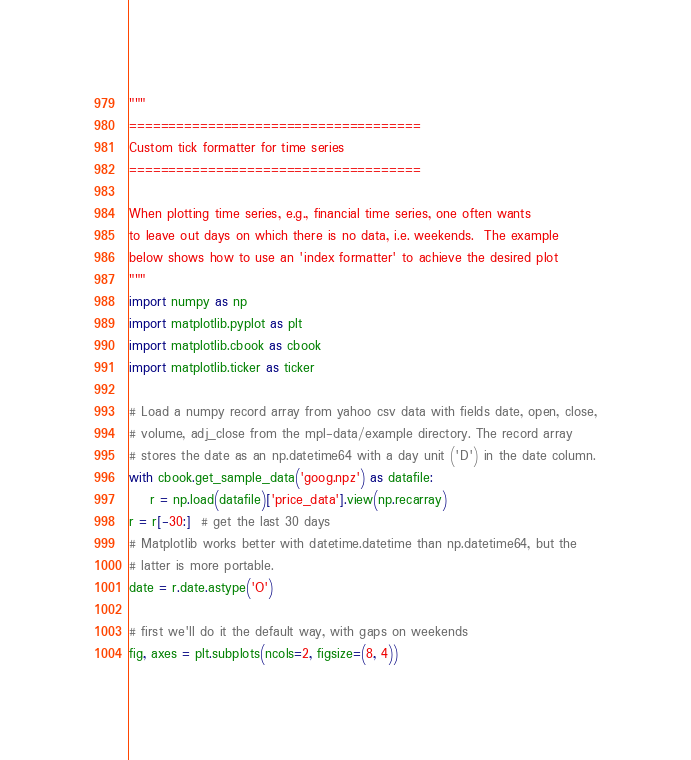<code> <loc_0><loc_0><loc_500><loc_500><_Python_>"""
=====================================
Custom tick formatter for time series
=====================================

When plotting time series, e.g., financial time series, one often wants
to leave out days on which there is no data, i.e. weekends.  The example
below shows how to use an 'index formatter' to achieve the desired plot
"""
import numpy as np
import matplotlib.pyplot as plt
import matplotlib.cbook as cbook
import matplotlib.ticker as ticker

# Load a numpy record array from yahoo csv data with fields date, open, close,
# volume, adj_close from the mpl-data/example directory. The record array
# stores the date as an np.datetime64 with a day unit ('D') in the date column.
with cbook.get_sample_data('goog.npz') as datafile:
    r = np.load(datafile)['price_data'].view(np.recarray)
r = r[-30:]  # get the last 30 days
# Matplotlib works better with datetime.datetime than np.datetime64, but the
# latter is more portable.
date = r.date.astype('O')

# first we'll do it the default way, with gaps on weekends
fig, axes = plt.subplots(ncols=2, figsize=(8, 4))</code> 